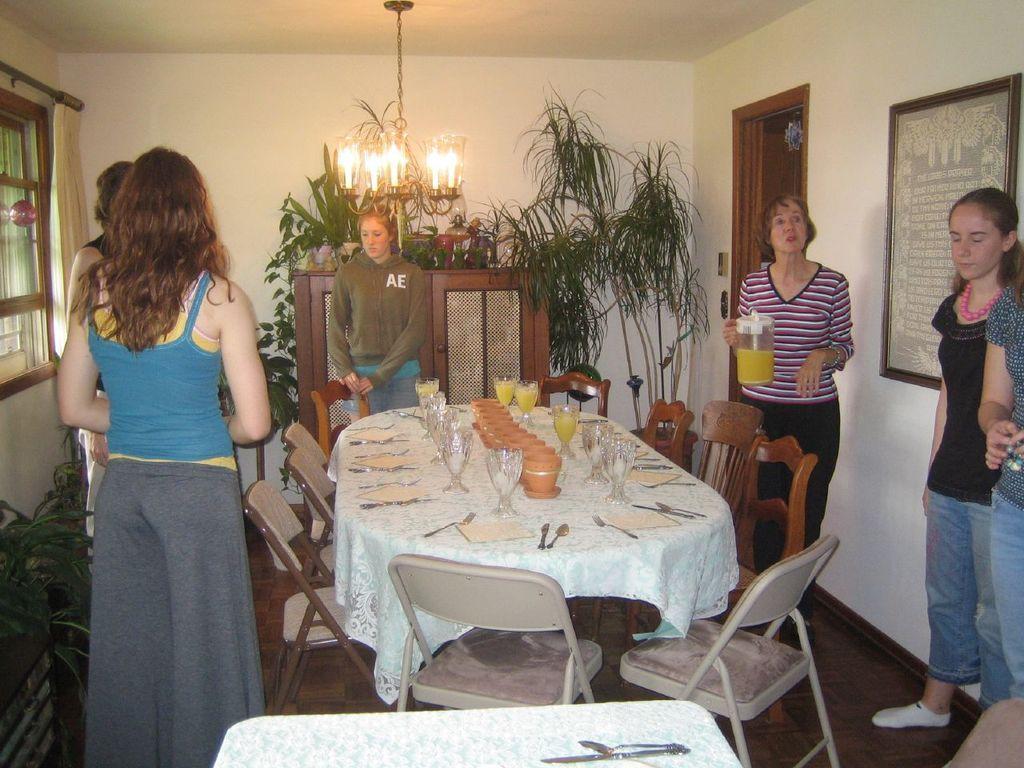Please provide a concise description of this image. In this image I can see number of people are standing. Here I can see number of chairs around this table. On this table i can see few glasses. In the background I can see few plants. 